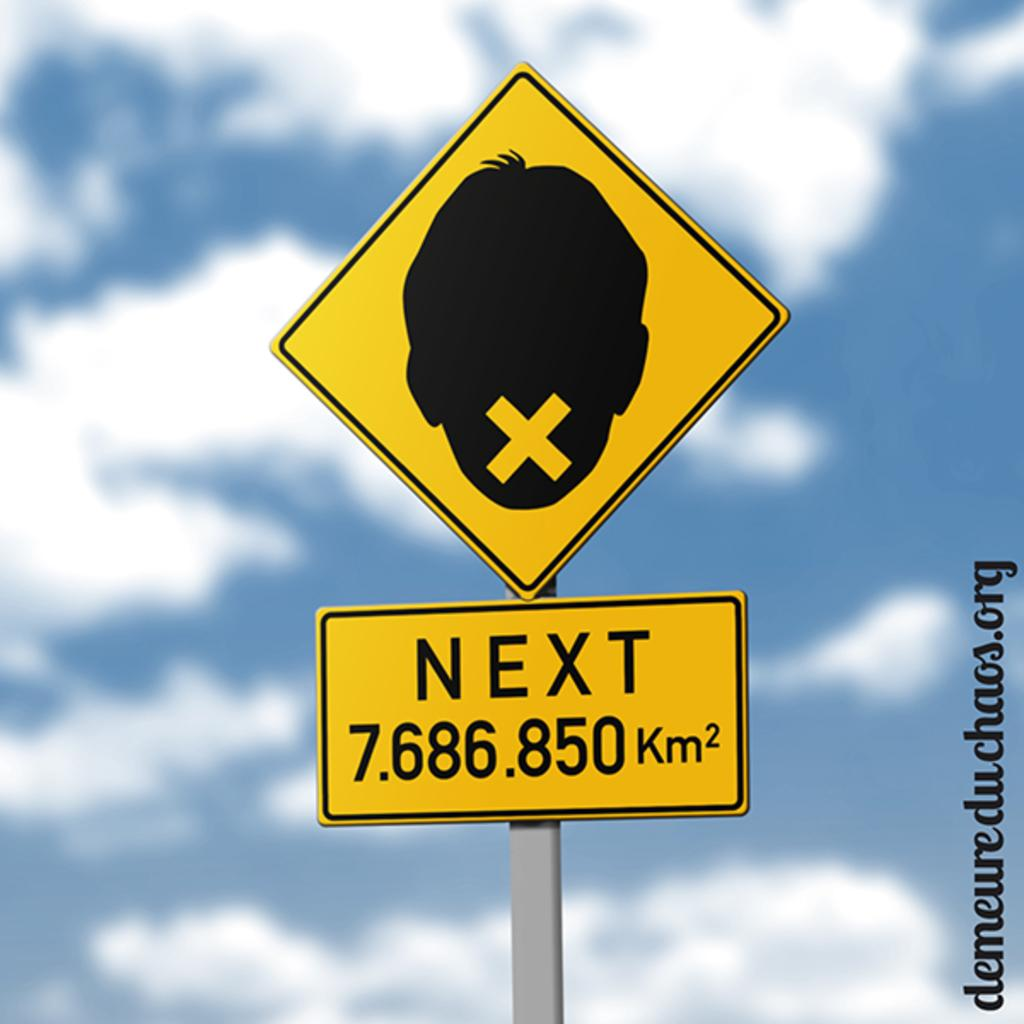Provide a one-sentence caption for the provided image. road sign that have a boy head with a x on it and next sign. 